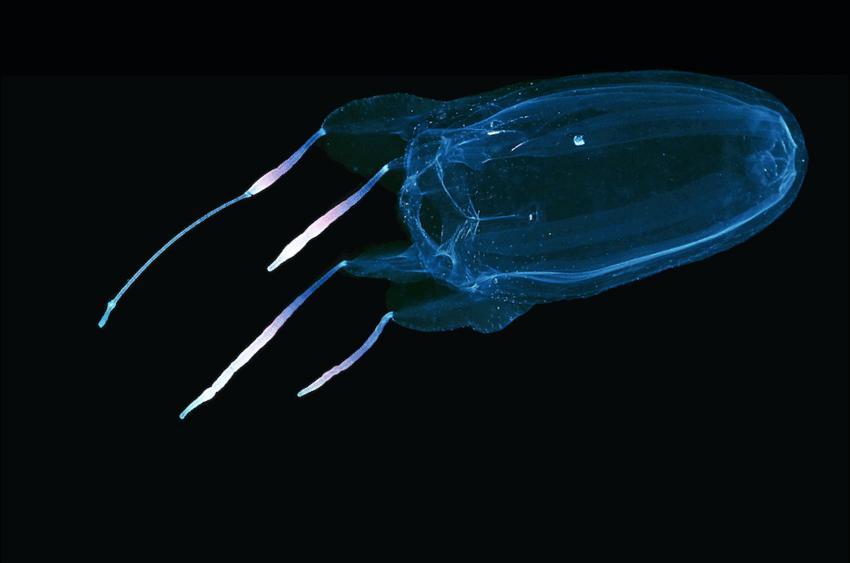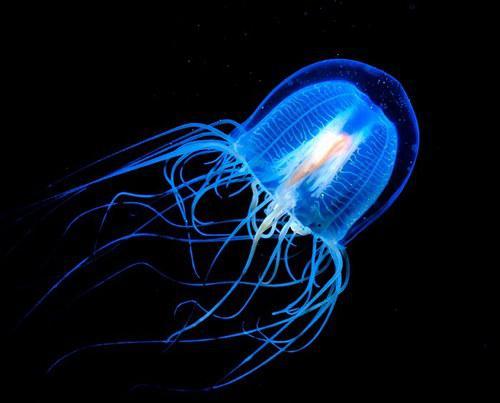The first image is the image on the left, the second image is the image on the right. For the images displayed, is the sentence "Each image shows a jellyfish with a dome-shaped 'body' with only wisps of white visible inside it, and long, stringlike tentacles flowing from it." factually correct? Answer yes or no. No. 